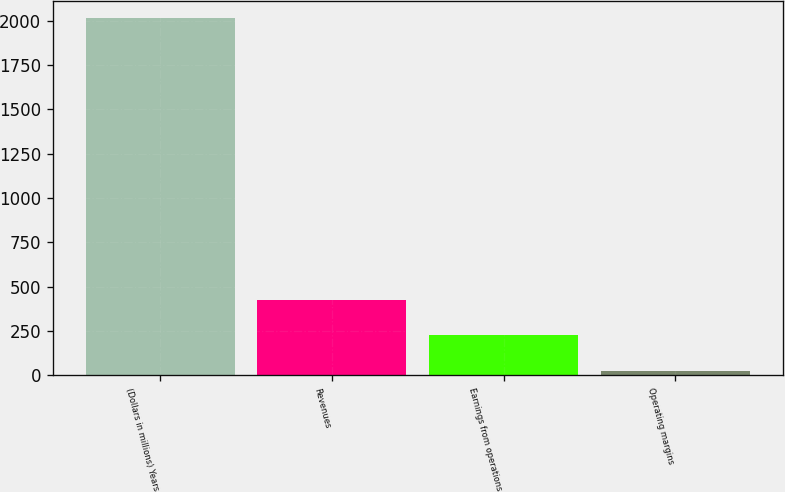Convert chart. <chart><loc_0><loc_0><loc_500><loc_500><bar_chart><fcel>(Dollars in millions) Years<fcel>Revenues<fcel>Earnings from operations<fcel>Operating margins<nl><fcel>2013<fcel>423.4<fcel>224.7<fcel>26<nl></chart> 